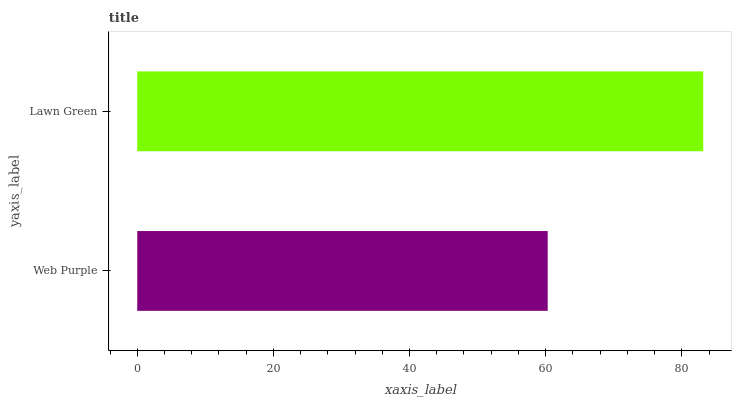Is Web Purple the minimum?
Answer yes or no. Yes. Is Lawn Green the maximum?
Answer yes or no. Yes. Is Lawn Green the minimum?
Answer yes or no. No. Is Lawn Green greater than Web Purple?
Answer yes or no. Yes. Is Web Purple less than Lawn Green?
Answer yes or no. Yes. Is Web Purple greater than Lawn Green?
Answer yes or no. No. Is Lawn Green less than Web Purple?
Answer yes or no. No. Is Lawn Green the high median?
Answer yes or no. Yes. Is Web Purple the low median?
Answer yes or no. Yes. Is Web Purple the high median?
Answer yes or no. No. Is Lawn Green the low median?
Answer yes or no. No. 